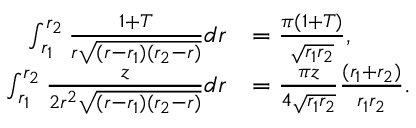Convert formula to latex. <formula><loc_0><loc_0><loc_500><loc_500>\begin{array} { r l } { \int _ { r _ { 1 } } ^ { r _ { 2 } } \frac { 1 + T } { r \sqrt { ( r - r _ { 1 } ) ( r _ { 2 } - r ) } } d r } & { = \frac { \pi ( 1 + T ) } { \sqrt { r _ { 1 } r _ { 2 } } } , } \\ { \int _ { r _ { 1 } } ^ { r _ { 2 } } \frac { z } { 2 r ^ { 2 } \sqrt { ( r - r _ { 1 } ) ( r _ { 2 } - r ) } } d r } & { = \frac { \pi z } { 4 \sqrt { r _ { 1 } r _ { 2 } } } \frac { ( r _ { 1 } + r _ { 2 } ) } { r _ { 1 } r _ { 2 } } . } \end{array}</formula> 